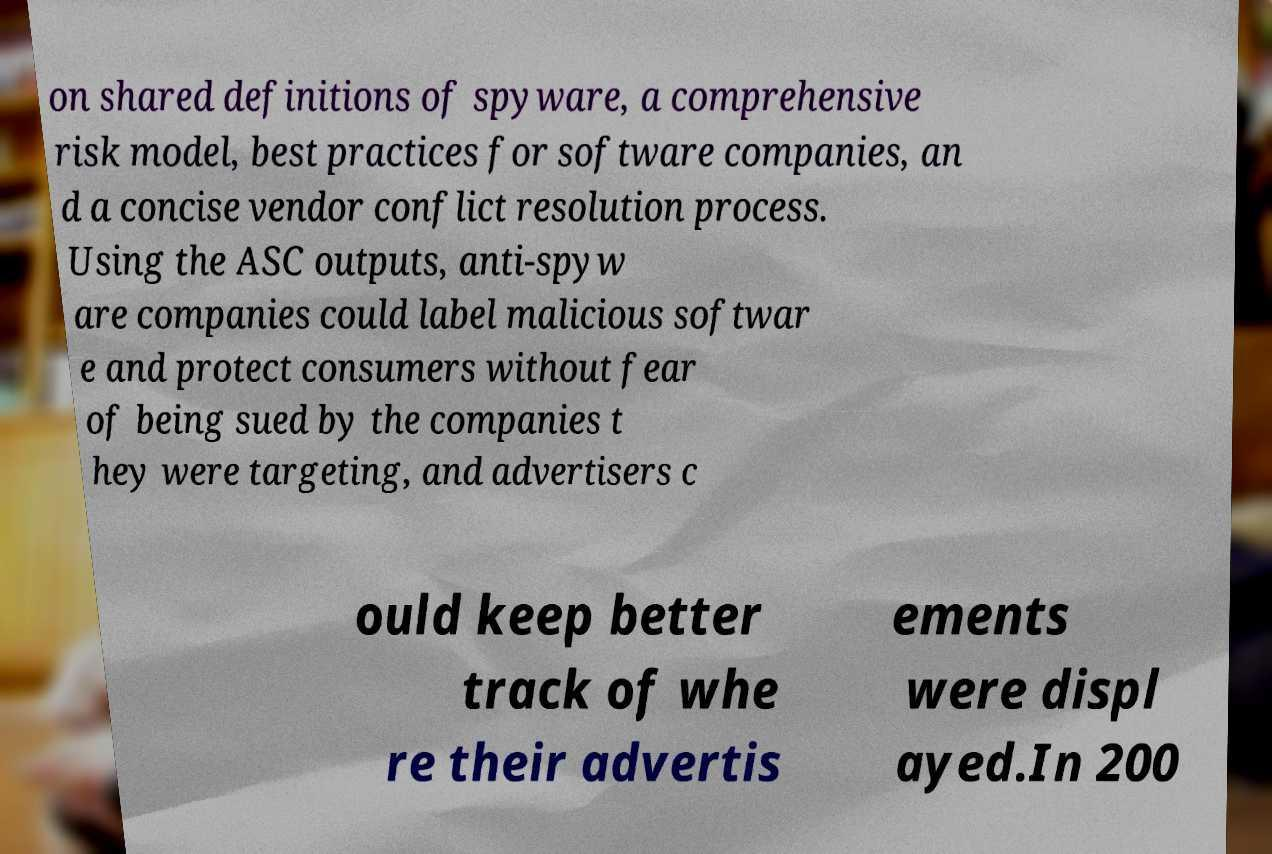Please read and relay the text visible in this image. What does it say? on shared definitions of spyware, a comprehensive risk model, best practices for software companies, an d a concise vendor conflict resolution process. Using the ASC outputs, anti-spyw are companies could label malicious softwar e and protect consumers without fear of being sued by the companies t hey were targeting, and advertisers c ould keep better track of whe re their advertis ements were displ ayed.In 200 